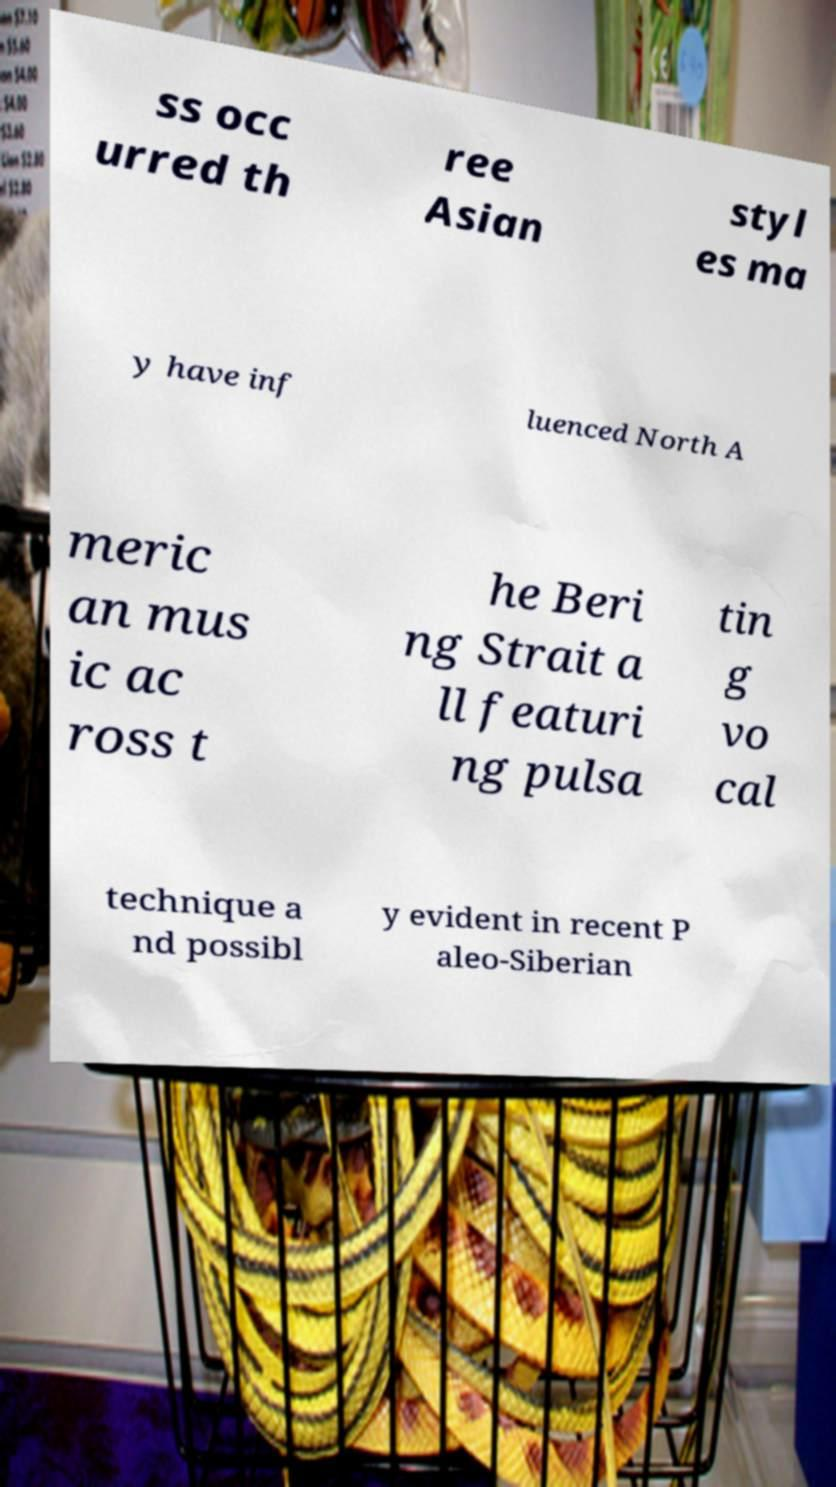I need the written content from this picture converted into text. Can you do that? ss occ urred th ree Asian styl es ma y have inf luenced North A meric an mus ic ac ross t he Beri ng Strait a ll featuri ng pulsa tin g vo cal technique a nd possibl y evident in recent P aleo-Siberian 